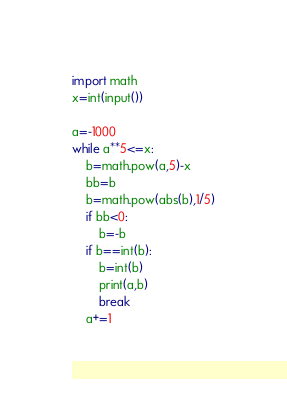<code> <loc_0><loc_0><loc_500><loc_500><_Python_>import math
x=int(input())

a=-1000
while a**5<=x:
    b=math.pow(a,5)-x
    bb=b
    b=math.pow(abs(b),1/5)
    if bb<0:
        b=-b
    if b==int(b):
        b=int(b)
        print(a,b)
        break
    a+=1
</code> 